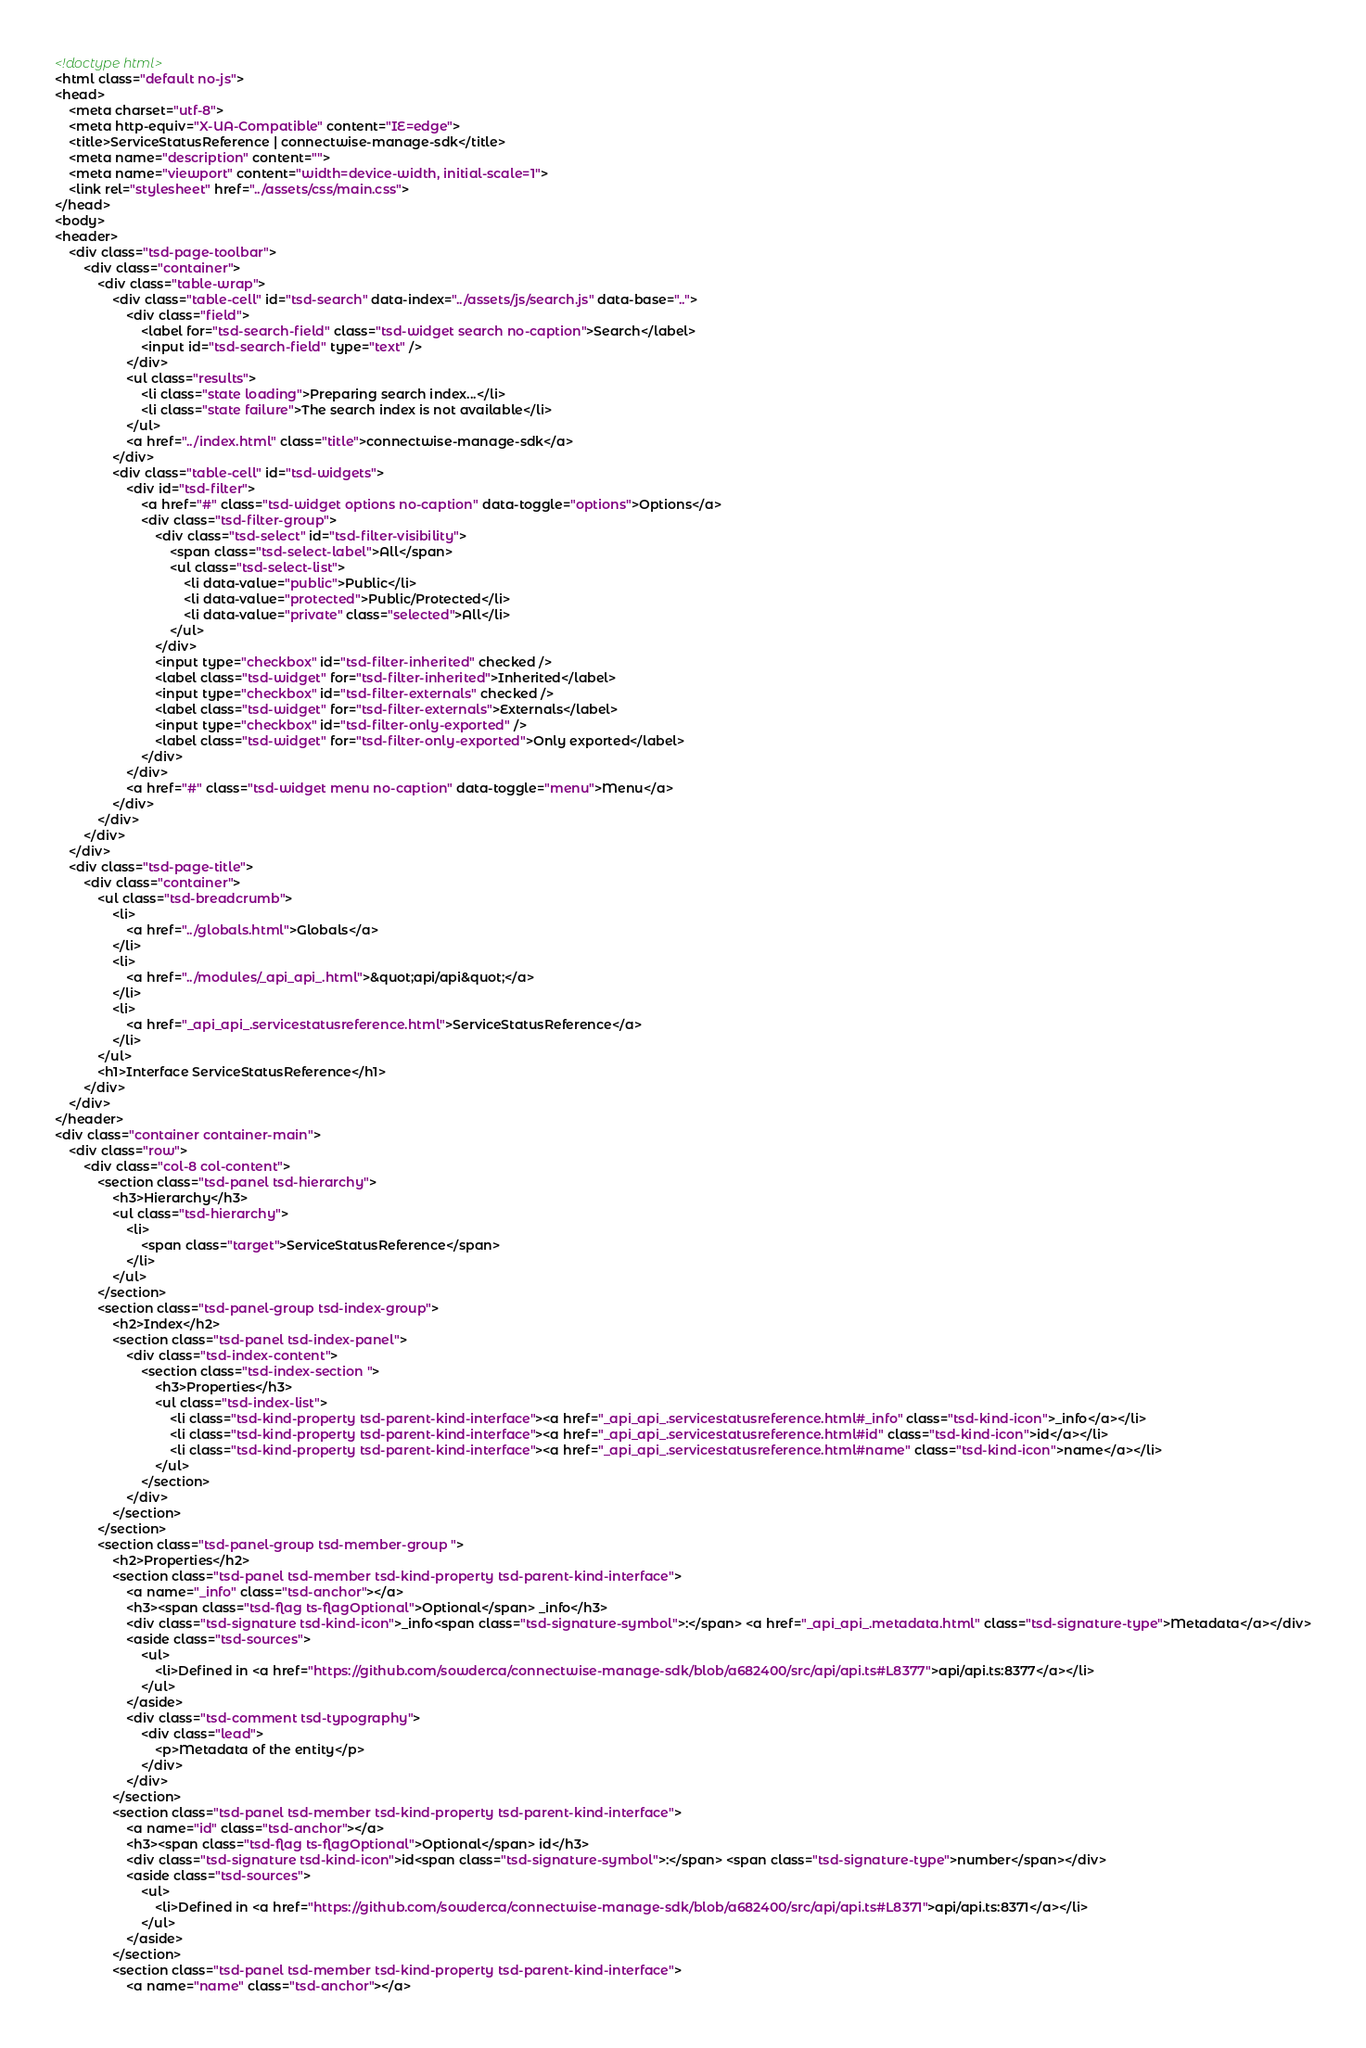Convert code to text. <code><loc_0><loc_0><loc_500><loc_500><_HTML_><!doctype html>
<html class="default no-js">
<head>
	<meta charset="utf-8">
	<meta http-equiv="X-UA-Compatible" content="IE=edge">
	<title>ServiceStatusReference | connectwise-manage-sdk</title>
	<meta name="description" content="">
	<meta name="viewport" content="width=device-width, initial-scale=1">
	<link rel="stylesheet" href="../assets/css/main.css">
</head>
<body>
<header>
	<div class="tsd-page-toolbar">
		<div class="container">
			<div class="table-wrap">
				<div class="table-cell" id="tsd-search" data-index="../assets/js/search.js" data-base="..">
					<div class="field">
						<label for="tsd-search-field" class="tsd-widget search no-caption">Search</label>
						<input id="tsd-search-field" type="text" />
					</div>
					<ul class="results">
						<li class="state loading">Preparing search index...</li>
						<li class="state failure">The search index is not available</li>
					</ul>
					<a href="../index.html" class="title">connectwise-manage-sdk</a>
				</div>
				<div class="table-cell" id="tsd-widgets">
					<div id="tsd-filter">
						<a href="#" class="tsd-widget options no-caption" data-toggle="options">Options</a>
						<div class="tsd-filter-group">
							<div class="tsd-select" id="tsd-filter-visibility">
								<span class="tsd-select-label">All</span>
								<ul class="tsd-select-list">
									<li data-value="public">Public</li>
									<li data-value="protected">Public/Protected</li>
									<li data-value="private" class="selected">All</li>
								</ul>
							</div>
							<input type="checkbox" id="tsd-filter-inherited" checked />
							<label class="tsd-widget" for="tsd-filter-inherited">Inherited</label>
							<input type="checkbox" id="tsd-filter-externals" checked />
							<label class="tsd-widget" for="tsd-filter-externals">Externals</label>
							<input type="checkbox" id="tsd-filter-only-exported" />
							<label class="tsd-widget" for="tsd-filter-only-exported">Only exported</label>
						</div>
					</div>
					<a href="#" class="tsd-widget menu no-caption" data-toggle="menu">Menu</a>
				</div>
			</div>
		</div>
	</div>
	<div class="tsd-page-title">
		<div class="container">
			<ul class="tsd-breadcrumb">
				<li>
					<a href="../globals.html">Globals</a>
				</li>
				<li>
					<a href="../modules/_api_api_.html">&quot;api/api&quot;</a>
				</li>
				<li>
					<a href="_api_api_.servicestatusreference.html">ServiceStatusReference</a>
				</li>
			</ul>
			<h1>Interface ServiceStatusReference</h1>
		</div>
	</div>
</header>
<div class="container container-main">
	<div class="row">
		<div class="col-8 col-content">
			<section class="tsd-panel tsd-hierarchy">
				<h3>Hierarchy</h3>
				<ul class="tsd-hierarchy">
					<li>
						<span class="target">ServiceStatusReference</span>
					</li>
				</ul>
			</section>
			<section class="tsd-panel-group tsd-index-group">
				<h2>Index</h2>
				<section class="tsd-panel tsd-index-panel">
					<div class="tsd-index-content">
						<section class="tsd-index-section ">
							<h3>Properties</h3>
							<ul class="tsd-index-list">
								<li class="tsd-kind-property tsd-parent-kind-interface"><a href="_api_api_.servicestatusreference.html#_info" class="tsd-kind-icon">_info</a></li>
								<li class="tsd-kind-property tsd-parent-kind-interface"><a href="_api_api_.servicestatusreference.html#id" class="tsd-kind-icon">id</a></li>
								<li class="tsd-kind-property tsd-parent-kind-interface"><a href="_api_api_.servicestatusreference.html#name" class="tsd-kind-icon">name</a></li>
							</ul>
						</section>
					</div>
				</section>
			</section>
			<section class="tsd-panel-group tsd-member-group ">
				<h2>Properties</h2>
				<section class="tsd-panel tsd-member tsd-kind-property tsd-parent-kind-interface">
					<a name="_info" class="tsd-anchor"></a>
					<h3><span class="tsd-flag ts-flagOptional">Optional</span> _info</h3>
					<div class="tsd-signature tsd-kind-icon">_info<span class="tsd-signature-symbol">:</span> <a href="_api_api_.metadata.html" class="tsd-signature-type">Metadata</a></div>
					<aside class="tsd-sources">
						<ul>
							<li>Defined in <a href="https://github.com/sowderca/connectwise-manage-sdk/blob/a682400/src/api/api.ts#L8377">api/api.ts:8377</a></li>
						</ul>
					</aside>
					<div class="tsd-comment tsd-typography">
						<div class="lead">
							<p>Metadata of the entity</p>
						</div>
					</div>
				</section>
				<section class="tsd-panel tsd-member tsd-kind-property tsd-parent-kind-interface">
					<a name="id" class="tsd-anchor"></a>
					<h3><span class="tsd-flag ts-flagOptional">Optional</span> id</h3>
					<div class="tsd-signature tsd-kind-icon">id<span class="tsd-signature-symbol">:</span> <span class="tsd-signature-type">number</span></div>
					<aside class="tsd-sources">
						<ul>
							<li>Defined in <a href="https://github.com/sowderca/connectwise-manage-sdk/blob/a682400/src/api/api.ts#L8371">api/api.ts:8371</a></li>
						</ul>
					</aside>
				</section>
				<section class="tsd-panel tsd-member tsd-kind-property tsd-parent-kind-interface">
					<a name="name" class="tsd-anchor"></a></code> 